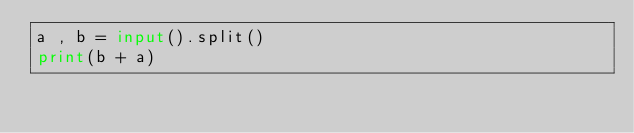<code> <loc_0><loc_0><loc_500><loc_500><_Python_>a , b = input().split()
print(b + a)</code> 